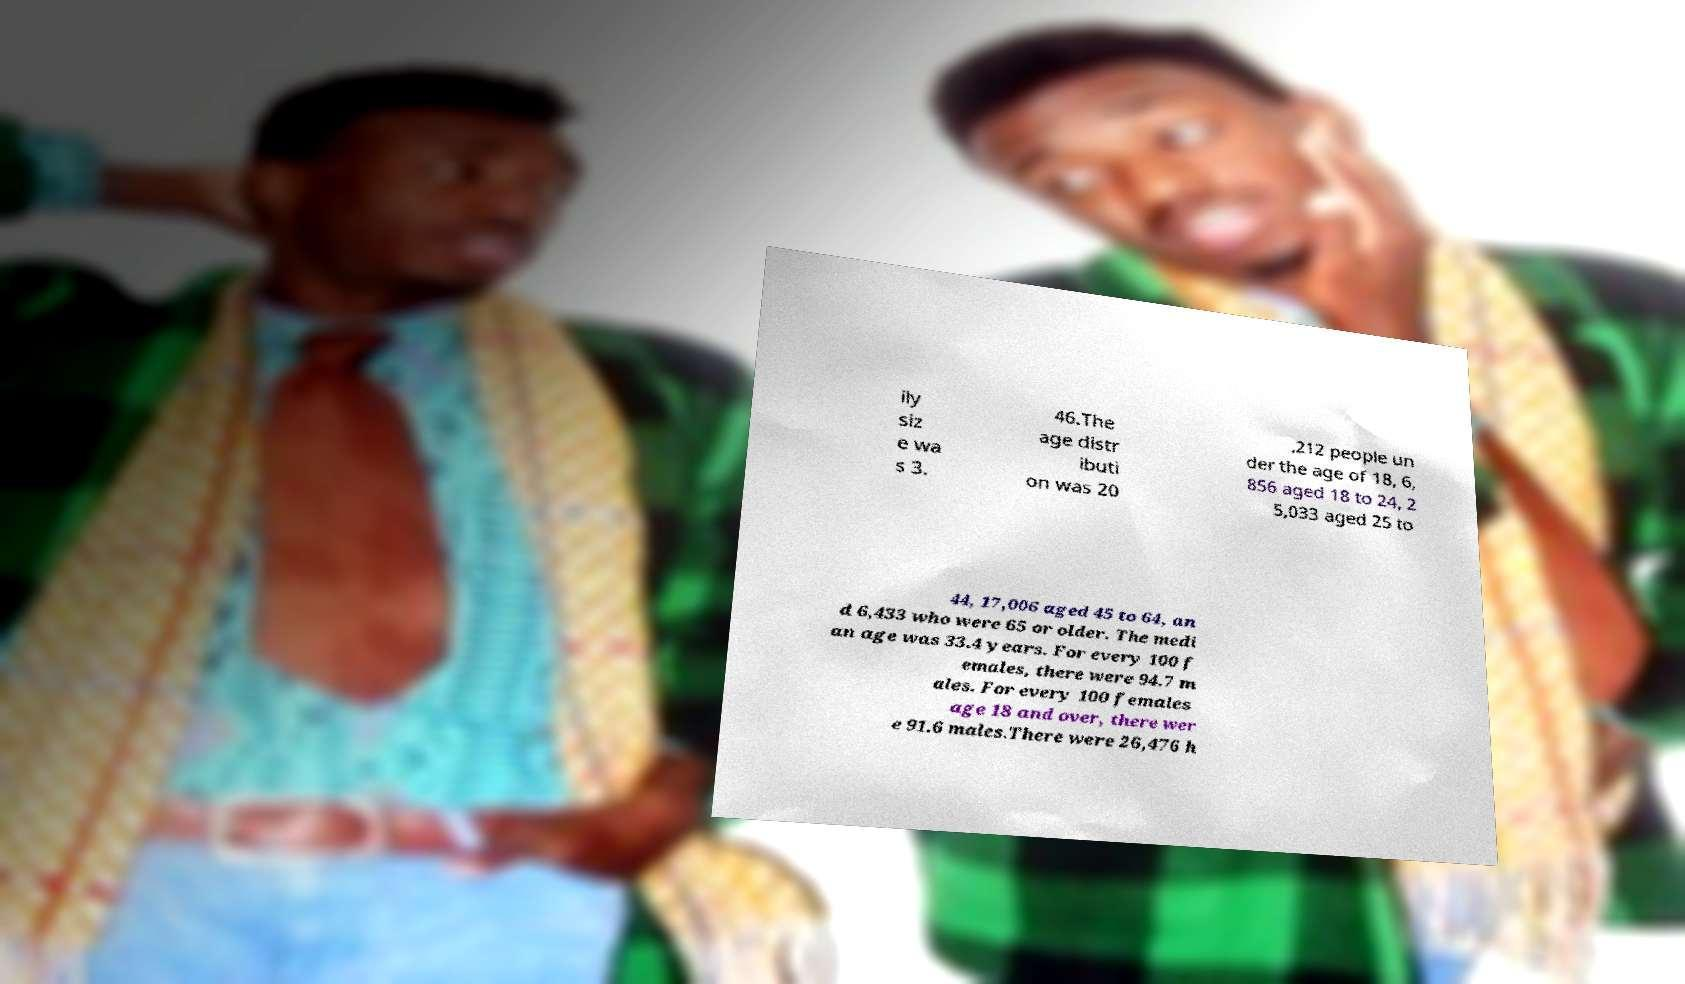I need the written content from this picture converted into text. Can you do that? ily siz e wa s 3. 46.The age distr ibuti on was 20 ,212 people un der the age of 18, 6, 856 aged 18 to 24, 2 5,033 aged 25 to 44, 17,006 aged 45 to 64, an d 6,433 who were 65 or older. The medi an age was 33.4 years. For every 100 f emales, there were 94.7 m ales. For every 100 females age 18 and over, there wer e 91.6 males.There were 26,476 h 